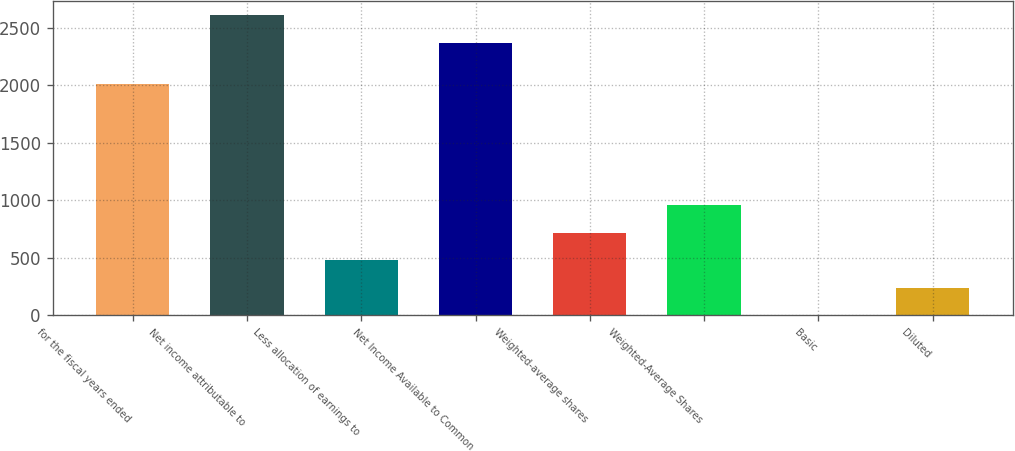Convert chart to OTSL. <chart><loc_0><loc_0><loc_500><loc_500><bar_chart><fcel>for the fiscal years ended<fcel>Net income attributable to<fcel>Less allocation of earnings to<fcel>Net Income Available to Common<fcel>Weighted-average shares<fcel>Weighted-Average Shares<fcel>Basic<fcel>Diluted<nl><fcel>2014<fcel>2608.05<fcel>479.89<fcel>2370<fcel>717.94<fcel>955.99<fcel>3.79<fcel>241.84<nl></chart> 